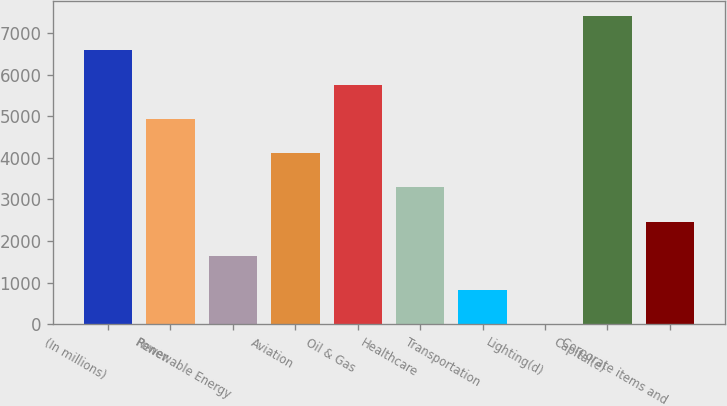Convert chart. <chart><loc_0><loc_0><loc_500><loc_500><bar_chart><fcel>(In millions)<fcel>Power<fcel>Renewable Energy<fcel>Aviation<fcel>Oil & Gas<fcel>Healthcare<fcel>Transportation<fcel>Lighting(d)<fcel>Capital(e)<fcel>Corporate items and<nl><fcel>6578.6<fcel>4934.2<fcel>1645.4<fcel>4112<fcel>5756.4<fcel>3289.8<fcel>823.2<fcel>1<fcel>7400.8<fcel>2467.6<nl></chart> 